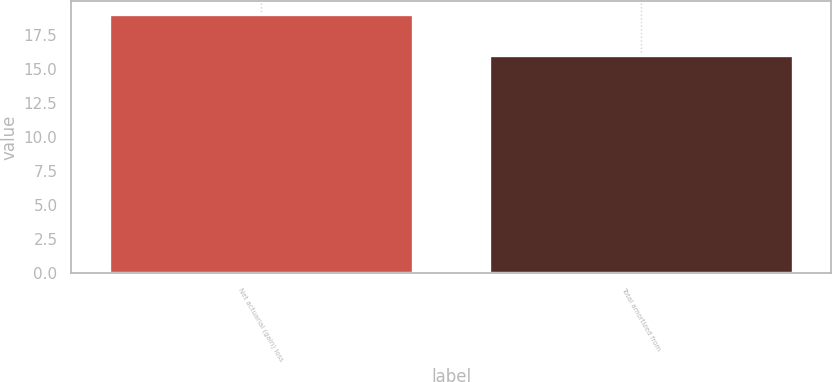Convert chart. <chart><loc_0><loc_0><loc_500><loc_500><bar_chart><fcel>Net actuarial (gain) loss<fcel>Total amortized from<nl><fcel>19<fcel>16<nl></chart> 